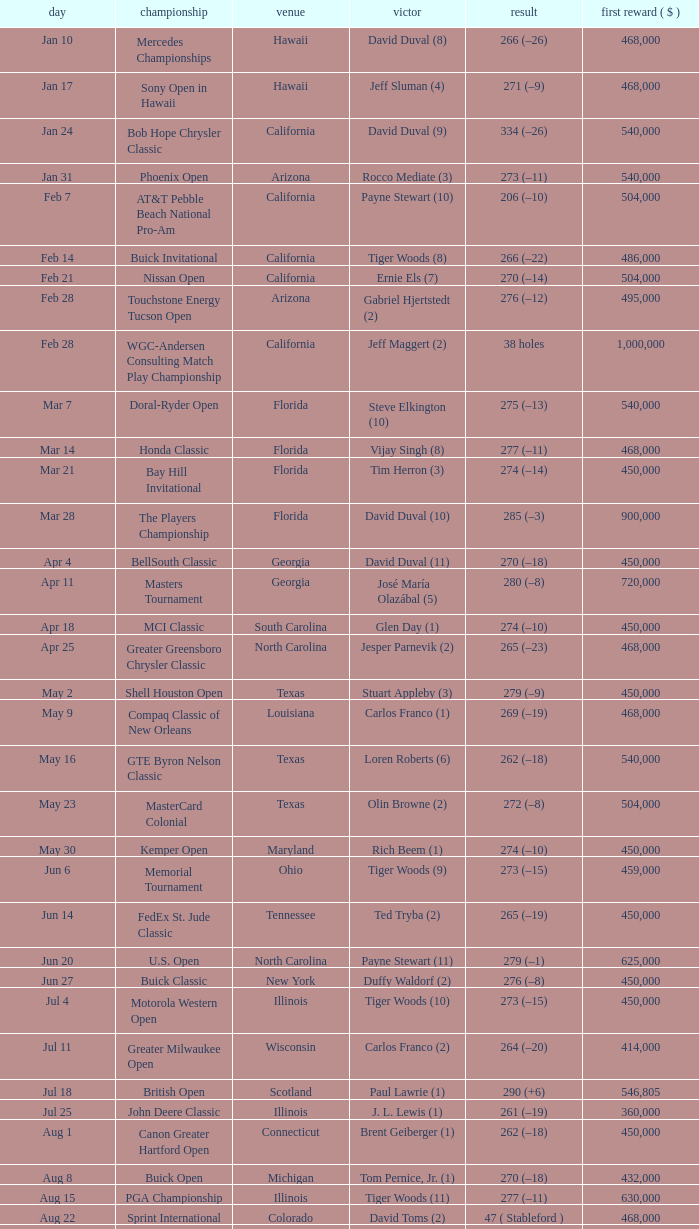What is the score of the B.C. Open in New York? 273 (–15). 